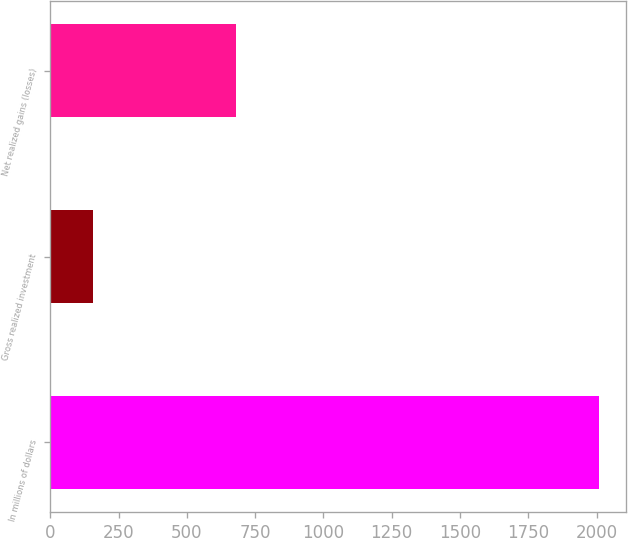Convert chart to OTSL. <chart><loc_0><loc_0><loc_500><loc_500><bar_chart><fcel>In millions of dollars<fcel>Gross realized investment<fcel>Net realized gains (losses)<nl><fcel>2008<fcel>158<fcel>679<nl></chart> 